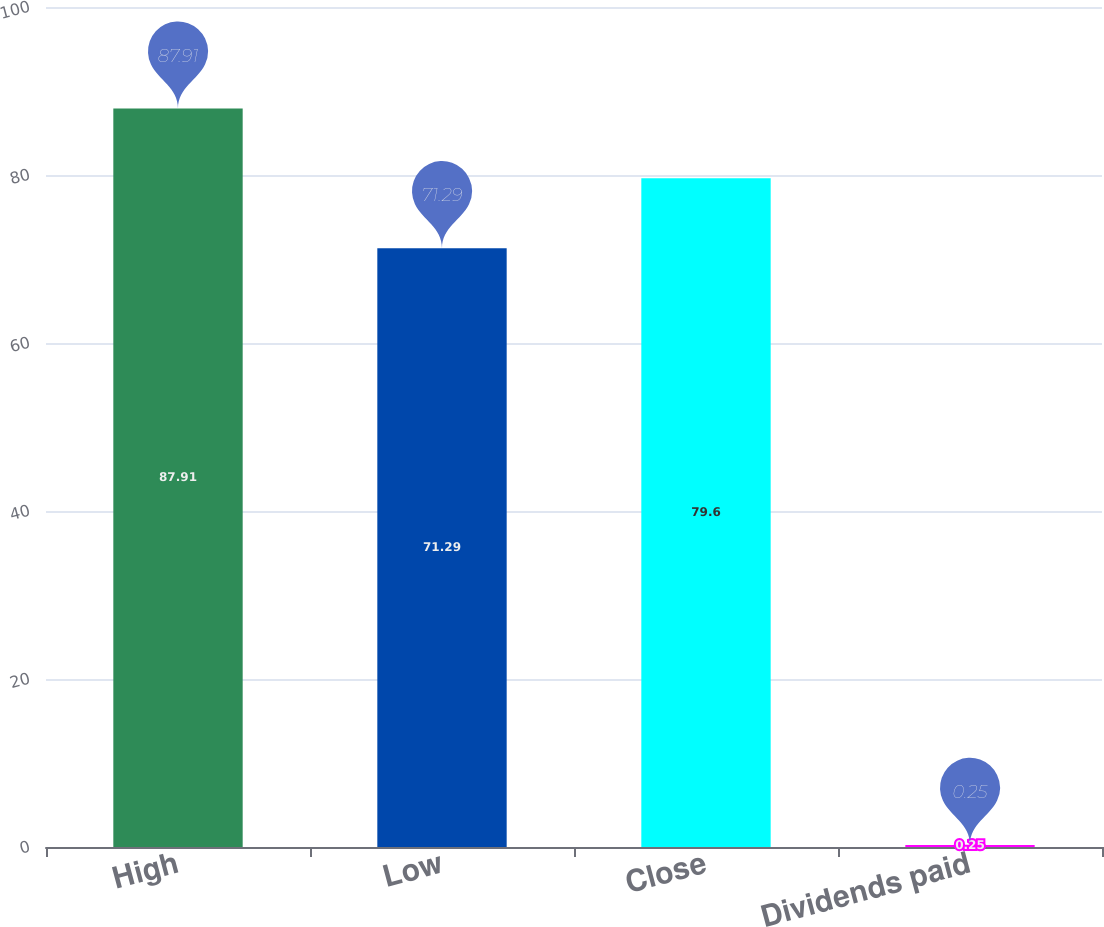Convert chart. <chart><loc_0><loc_0><loc_500><loc_500><bar_chart><fcel>High<fcel>Low<fcel>Close<fcel>Dividends paid<nl><fcel>87.91<fcel>71.29<fcel>79.6<fcel>0.25<nl></chart> 